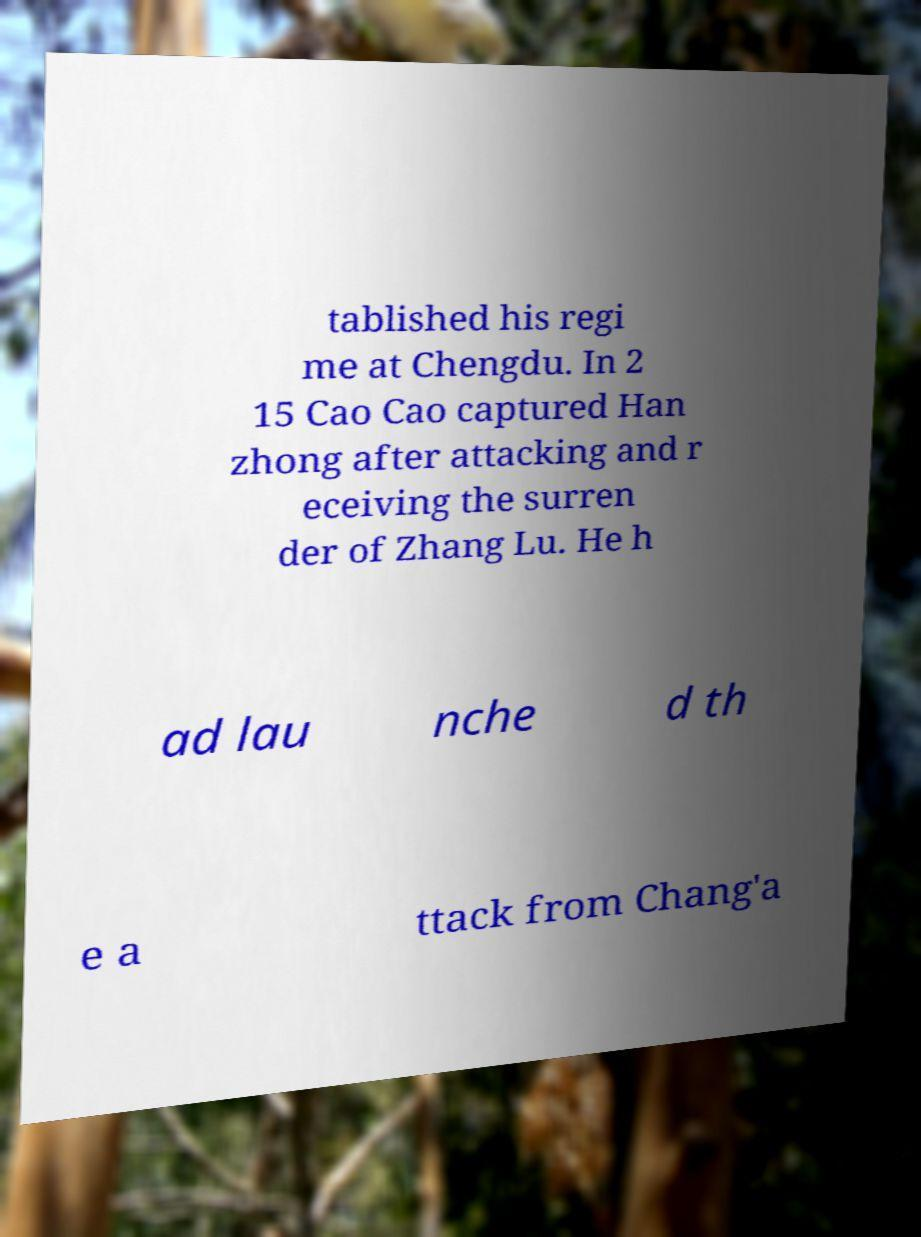There's text embedded in this image that I need extracted. Can you transcribe it verbatim? tablished his regi me at Chengdu. In 2 15 Cao Cao captured Han zhong after attacking and r eceiving the surren der of Zhang Lu. He h ad lau nche d th e a ttack from Chang'a 